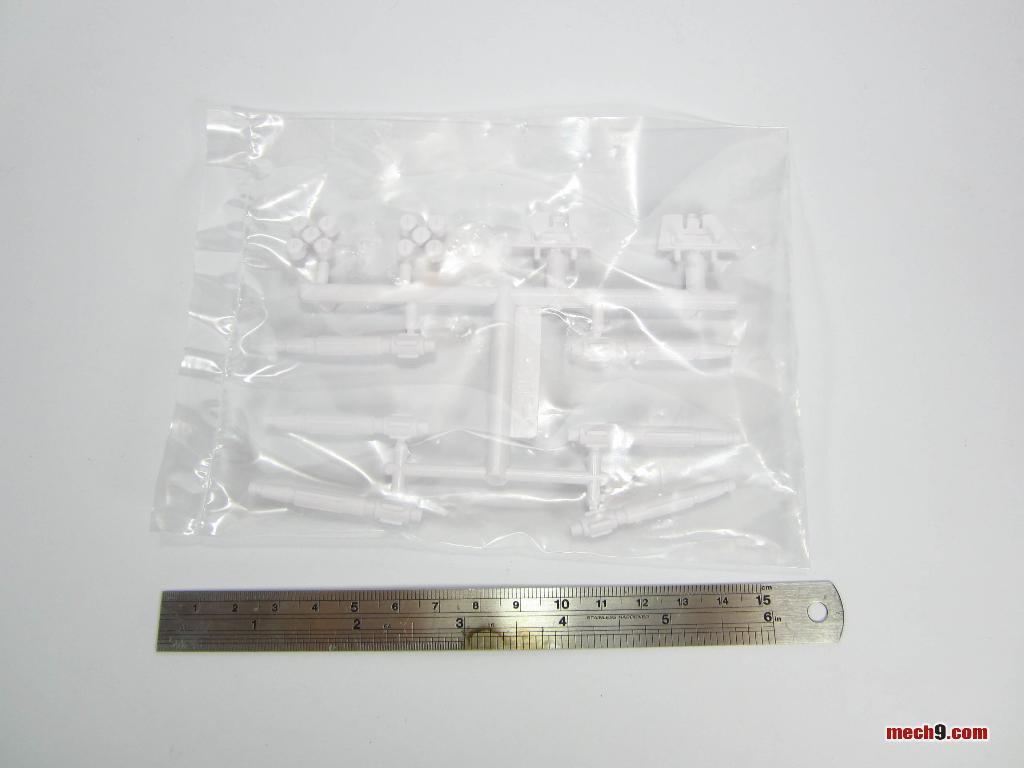<image>
Present a compact description of the photo's key features. Ruler measuring a Plastic bag that measures up to the number 15. 